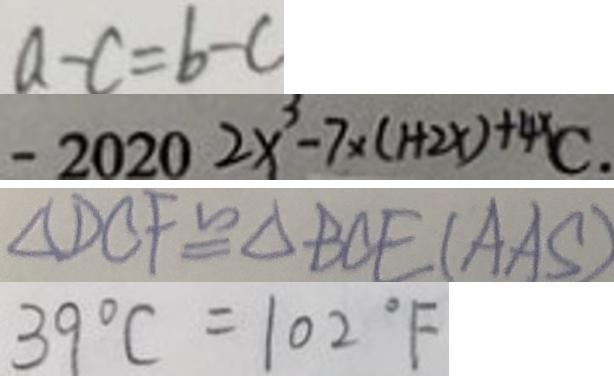Convert formula to latex. <formula><loc_0><loc_0><loc_500><loc_500>a - c = b - c 
 - 2 0 2 0 2 x ^ { 3 } - 7 \times ( 1 + 2 x ) + 4 x C . 
 \Delta B C F \cong \Delta B C E ( A A S ) 
 3 9 ^ { \circ } C = 1 0 2 ^ { \circ } F</formula> 